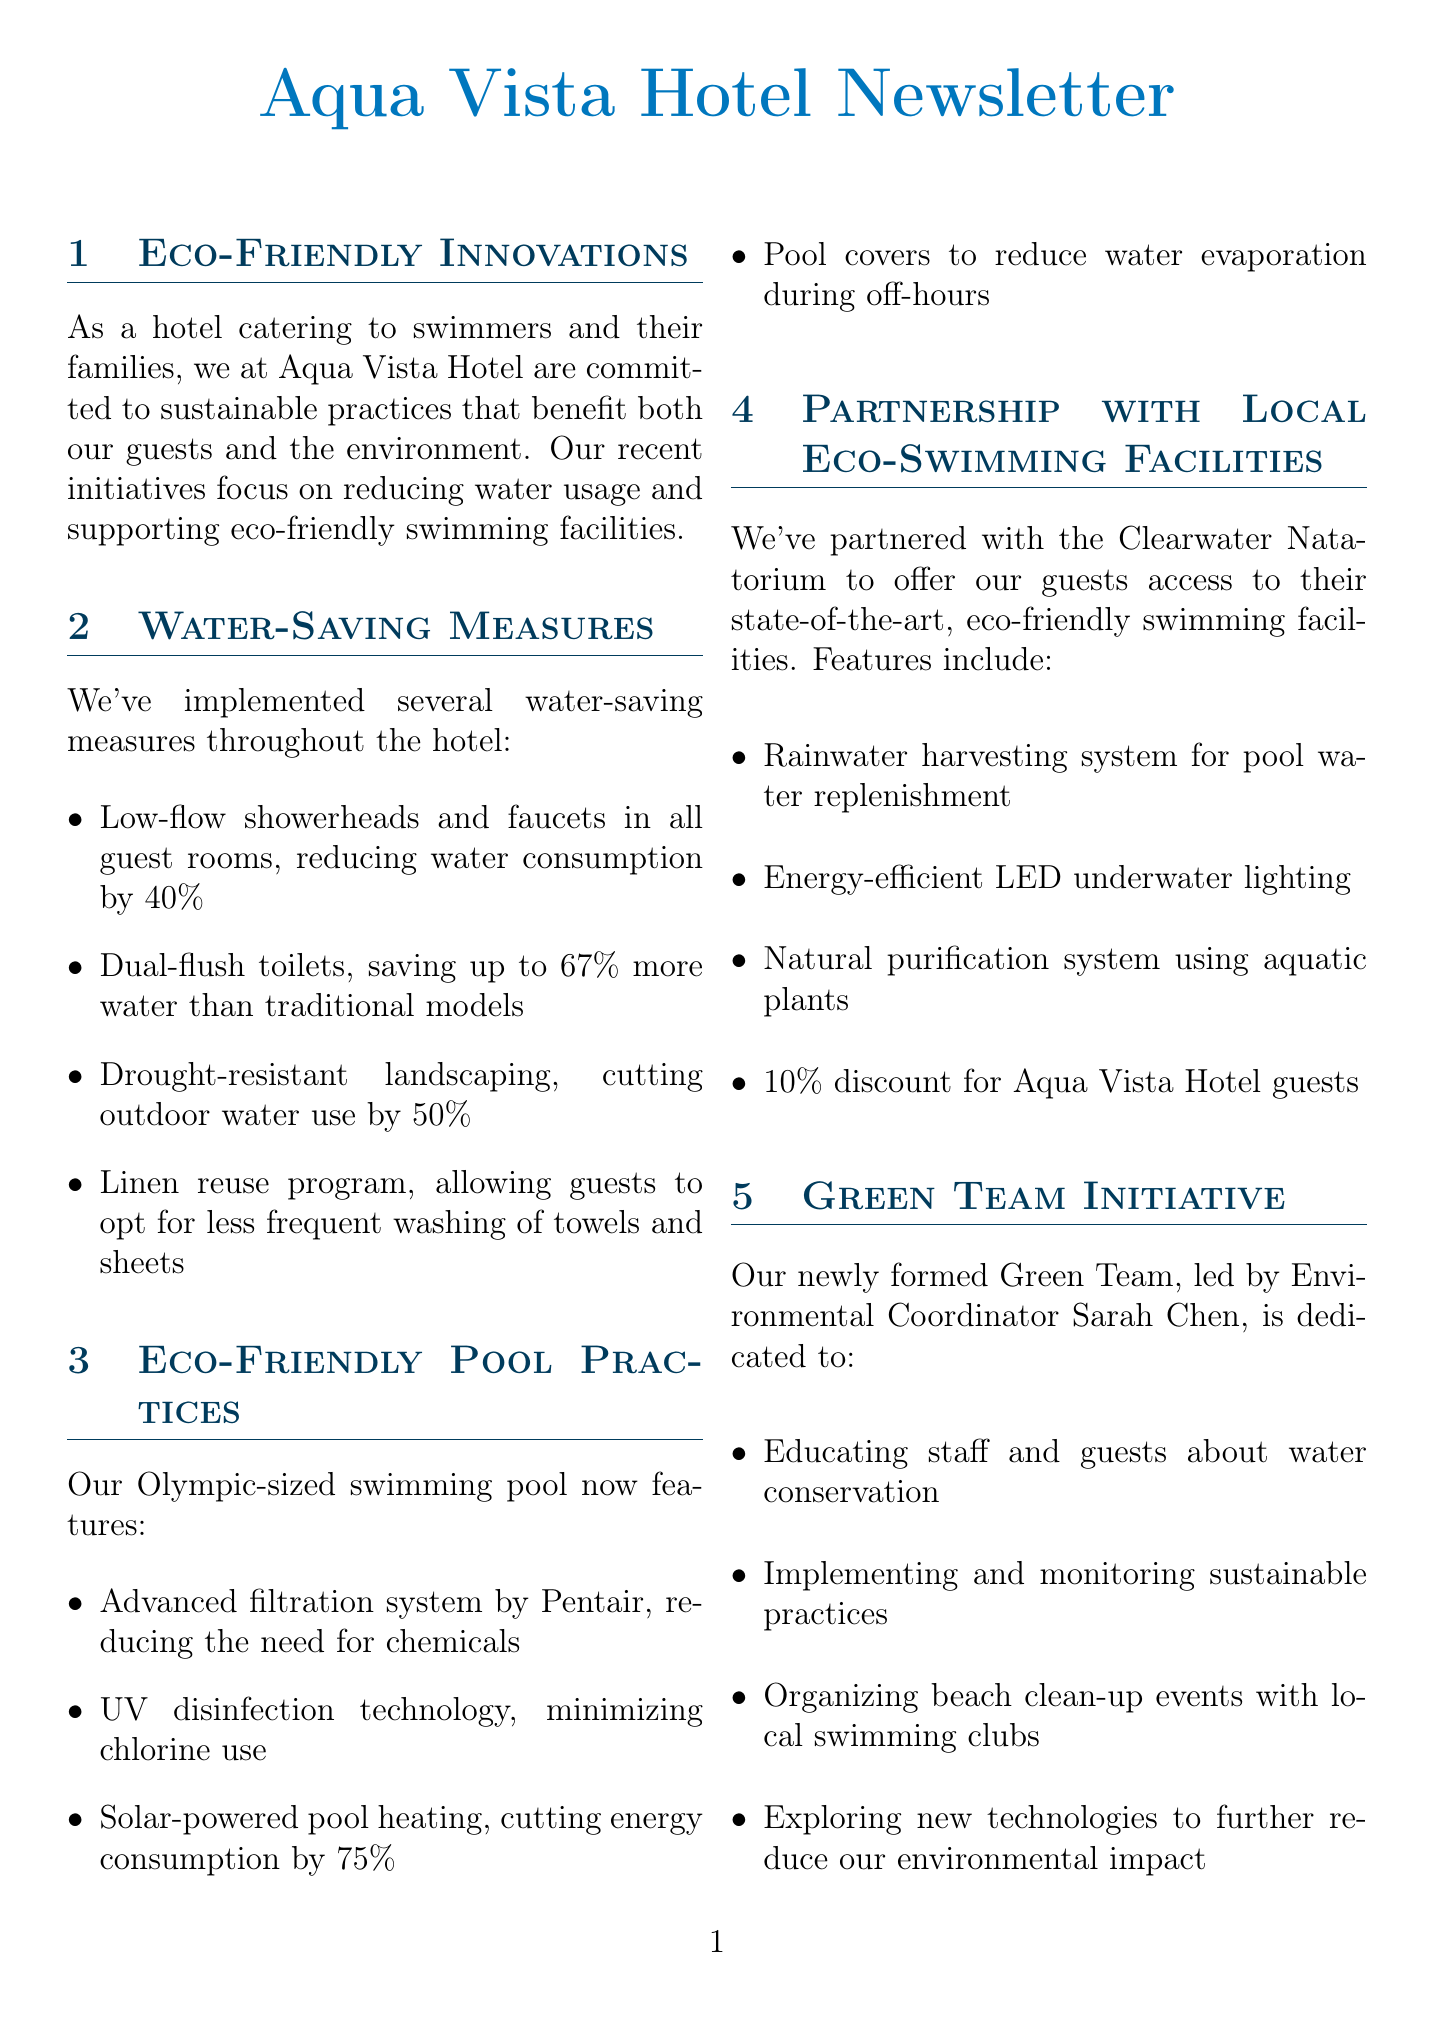What initiatives are highlighted for sustainability? The document mentions sustainable practices focused on reducing water usage and supporting eco-friendly swimming facilities.
Answer: reducing water usage and supporting eco-friendly swimming facilities What type of toilets does the hotel use? The hotel utilizes dual-flush toilets that save water compared to traditional models.
Answer: dual-flush toilets What percentage can guests save by using the linen reuse program? The linen reuse program allows guests to opt for less frequent washing of towels and sheets, indirectly helping save water but does not specify a percentage.
Answer: not specified How much does the solar-powered pool heating cut energy consumption? The solar-powered pool heating technology is mentioned as reducing energy consumption by 75%.
Answer: 75% What is the name of the Environmental Coordinator leading the Green Team? The new Green Team is led by Environmental Coordinator Sarah Chen.
Answer: Sarah Chen How much discount do Aqua Vista Hotel guests get at the Clearwater Natatorium? The hotel guests receive a discount on access to the Clearwater Natatorium's facilities.
Answer: 10% What is one of the future plans related to eco-friendly swimming facilities? The document lists several future projects, including a greywater recycling system that supports sustainability efforts.
Answer: greywater recycling system What special offer is available for eco-conscious swimmers? The document describes a discount for guests who book using a specific code.
Answer: 15% discount What initiative includes organizing beach clean-up events? The Green Team initiative is dedicated to organizing beach clean-up events with local swimming clubs.
Answer: Green Team initiative 